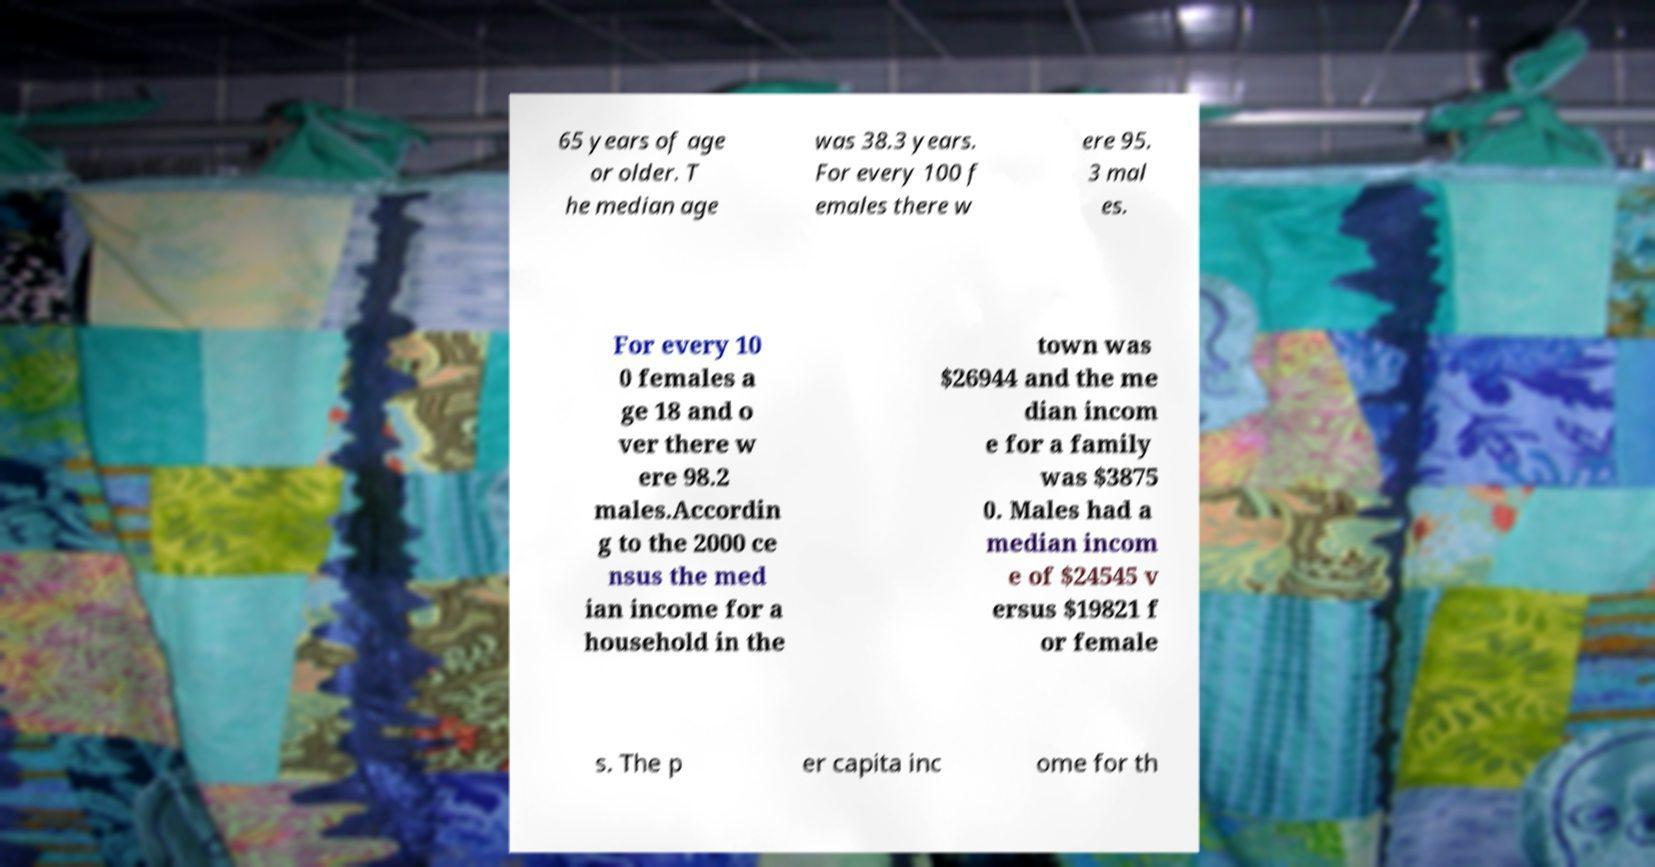What messages or text are displayed in this image? I need them in a readable, typed format. 65 years of age or older. T he median age was 38.3 years. For every 100 f emales there w ere 95. 3 mal es. For every 10 0 females a ge 18 and o ver there w ere 98.2 males.Accordin g to the 2000 ce nsus the med ian income for a household in the town was $26944 and the me dian incom e for a family was $3875 0. Males had a median incom e of $24545 v ersus $19821 f or female s. The p er capita inc ome for th 